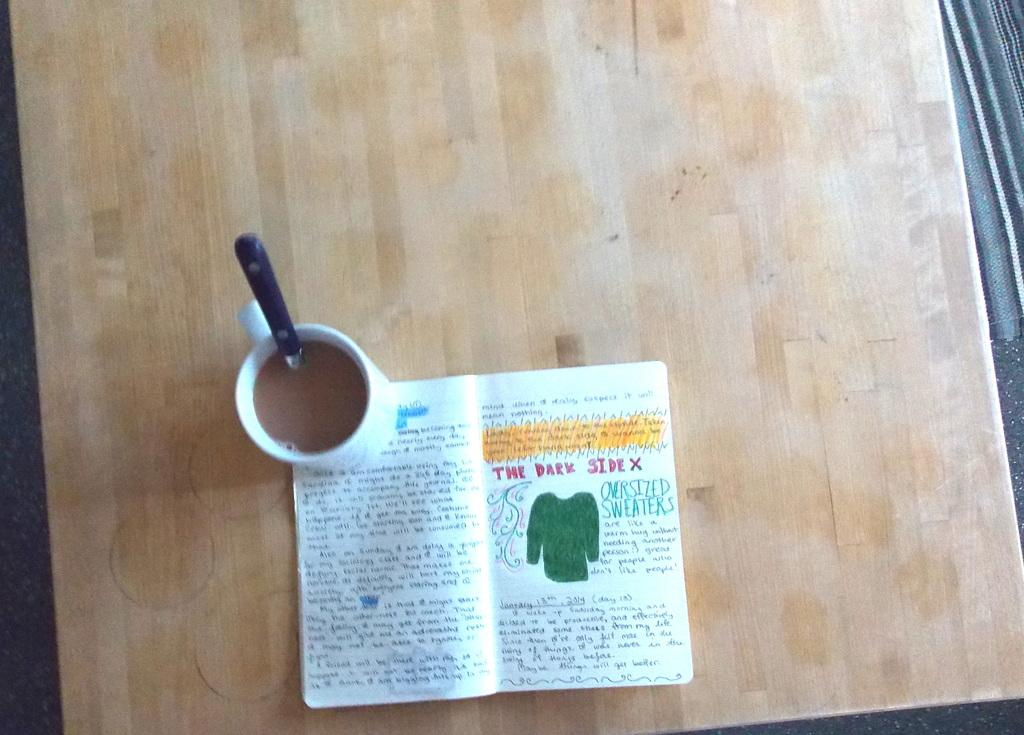Provide a one-sentence caption for the provided image. A coffee mug and a journal doodle book about the dark side and oversized sweaters. 